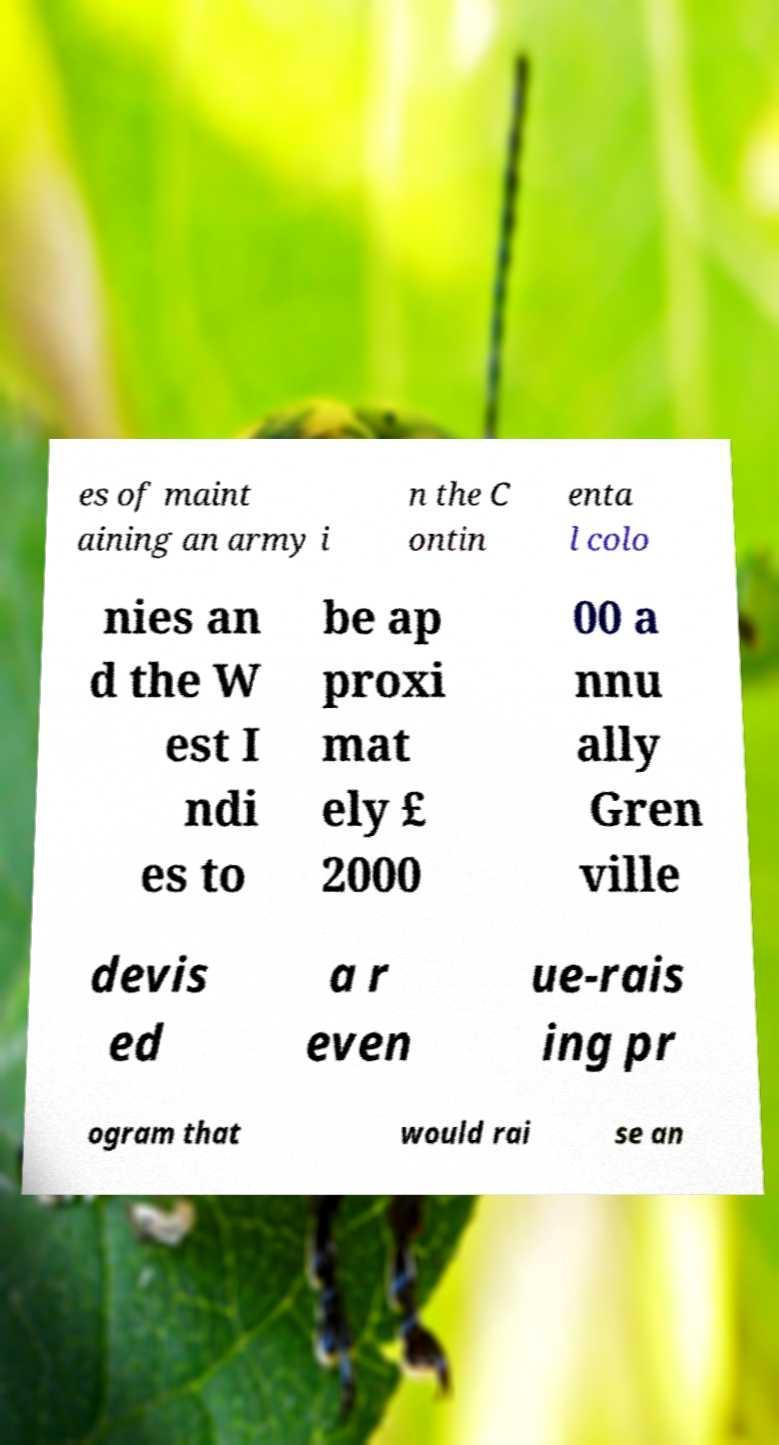Please identify and transcribe the text found in this image. es of maint aining an army i n the C ontin enta l colo nies an d the W est I ndi es to be ap proxi mat ely £ 2000 00 a nnu ally Gren ville devis ed a r even ue-rais ing pr ogram that would rai se an 